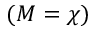<formula> <loc_0><loc_0><loc_500><loc_500>( M = \chi )</formula> 